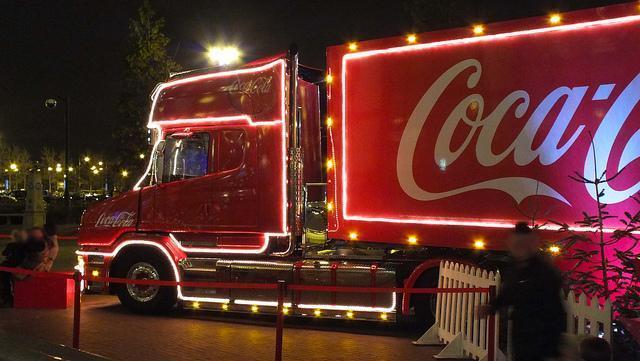How many bears are there?
Give a very brief answer. 0. 